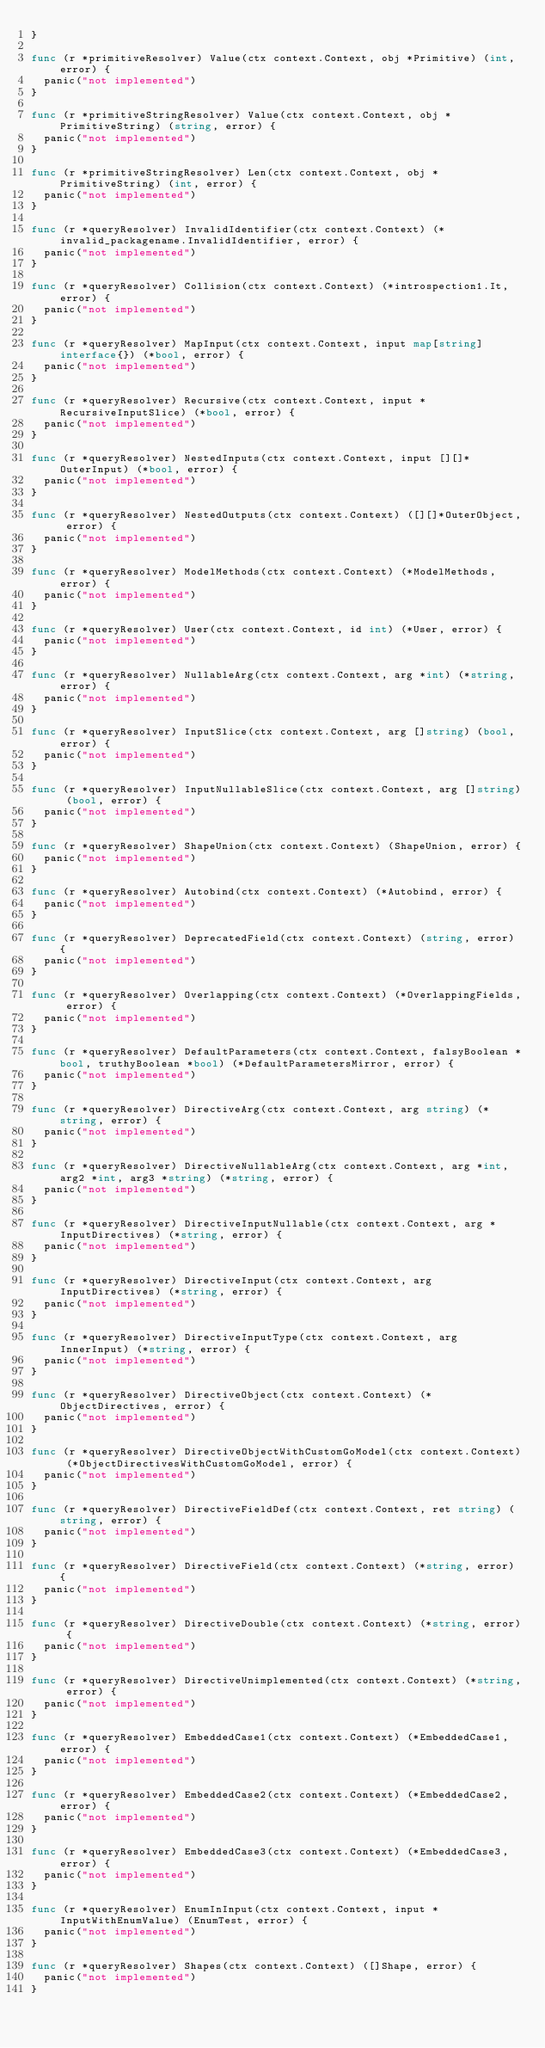<code> <loc_0><loc_0><loc_500><loc_500><_Go_>}

func (r *primitiveResolver) Value(ctx context.Context, obj *Primitive) (int, error) {
	panic("not implemented")
}

func (r *primitiveStringResolver) Value(ctx context.Context, obj *PrimitiveString) (string, error) {
	panic("not implemented")
}

func (r *primitiveStringResolver) Len(ctx context.Context, obj *PrimitiveString) (int, error) {
	panic("not implemented")
}

func (r *queryResolver) InvalidIdentifier(ctx context.Context) (*invalid_packagename.InvalidIdentifier, error) {
	panic("not implemented")
}

func (r *queryResolver) Collision(ctx context.Context) (*introspection1.It, error) {
	panic("not implemented")
}

func (r *queryResolver) MapInput(ctx context.Context, input map[string]interface{}) (*bool, error) {
	panic("not implemented")
}

func (r *queryResolver) Recursive(ctx context.Context, input *RecursiveInputSlice) (*bool, error) {
	panic("not implemented")
}

func (r *queryResolver) NestedInputs(ctx context.Context, input [][]*OuterInput) (*bool, error) {
	panic("not implemented")
}

func (r *queryResolver) NestedOutputs(ctx context.Context) ([][]*OuterObject, error) {
	panic("not implemented")
}

func (r *queryResolver) ModelMethods(ctx context.Context) (*ModelMethods, error) {
	panic("not implemented")
}

func (r *queryResolver) User(ctx context.Context, id int) (*User, error) {
	panic("not implemented")
}

func (r *queryResolver) NullableArg(ctx context.Context, arg *int) (*string, error) {
	panic("not implemented")
}

func (r *queryResolver) InputSlice(ctx context.Context, arg []string) (bool, error) {
	panic("not implemented")
}

func (r *queryResolver) InputNullableSlice(ctx context.Context, arg []string) (bool, error) {
	panic("not implemented")
}

func (r *queryResolver) ShapeUnion(ctx context.Context) (ShapeUnion, error) {
	panic("not implemented")
}

func (r *queryResolver) Autobind(ctx context.Context) (*Autobind, error) {
	panic("not implemented")
}

func (r *queryResolver) DeprecatedField(ctx context.Context) (string, error) {
	panic("not implemented")
}

func (r *queryResolver) Overlapping(ctx context.Context) (*OverlappingFields, error) {
	panic("not implemented")
}

func (r *queryResolver) DefaultParameters(ctx context.Context, falsyBoolean *bool, truthyBoolean *bool) (*DefaultParametersMirror, error) {
	panic("not implemented")
}

func (r *queryResolver) DirectiveArg(ctx context.Context, arg string) (*string, error) {
	panic("not implemented")
}

func (r *queryResolver) DirectiveNullableArg(ctx context.Context, arg *int, arg2 *int, arg3 *string) (*string, error) {
	panic("not implemented")
}

func (r *queryResolver) DirectiveInputNullable(ctx context.Context, arg *InputDirectives) (*string, error) {
	panic("not implemented")
}

func (r *queryResolver) DirectiveInput(ctx context.Context, arg InputDirectives) (*string, error) {
	panic("not implemented")
}

func (r *queryResolver) DirectiveInputType(ctx context.Context, arg InnerInput) (*string, error) {
	panic("not implemented")
}

func (r *queryResolver) DirectiveObject(ctx context.Context) (*ObjectDirectives, error) {
	panic("not implemented")
}

func (r *queryResolver) DirectiveObjectWithCustomGoModel(ctx context.Context) (*ObjectDirectivesWithCustomGoModel, error) {
	panic("not implemented")
}

func (r *queryResolver) DirectiveFieldDef(ctx context.Context, ret string) (string, error) {
	panic("not implemented")
}

func (r *queryResolver) DirectiveField(ctx context.Context) (*string, error) {
	panic("not implemented")
}

func (r *queryResolver) DirectiveDouble(ctx context.Context) (*string, error) {
	panic("not implemented")
}

func (r *queryResolver) DirectiveUnimplemented(ctx context.Context) (*string, error) {
	panic("not implemented")
}

func (r *queryResolver) EmbeddedCase1(ctx context.Context) (*EmbeddedCase1, error) {
	panic("not implemented")
}

func (r *queryResolver) EmbeddedCase2(ctx context.Context) (*EmbeddedCase2, error) {
	panic("not implemented")
}

func (r *queryResolver) EmbeddedCase3(ctx context.Context) (*EmbeddedCase3, error) {
	panic("not implemented")
}

func (r *queryResolver) EnumInInput(ctx context.Context, input *InputWithEnumValue) (EnumTest, error) {
	panic("not implemented")
}

func (r *queryResolver) Shapes(ctx context.Context) ([]Shape, error) {
	panic("not implemented")
}
</code> 